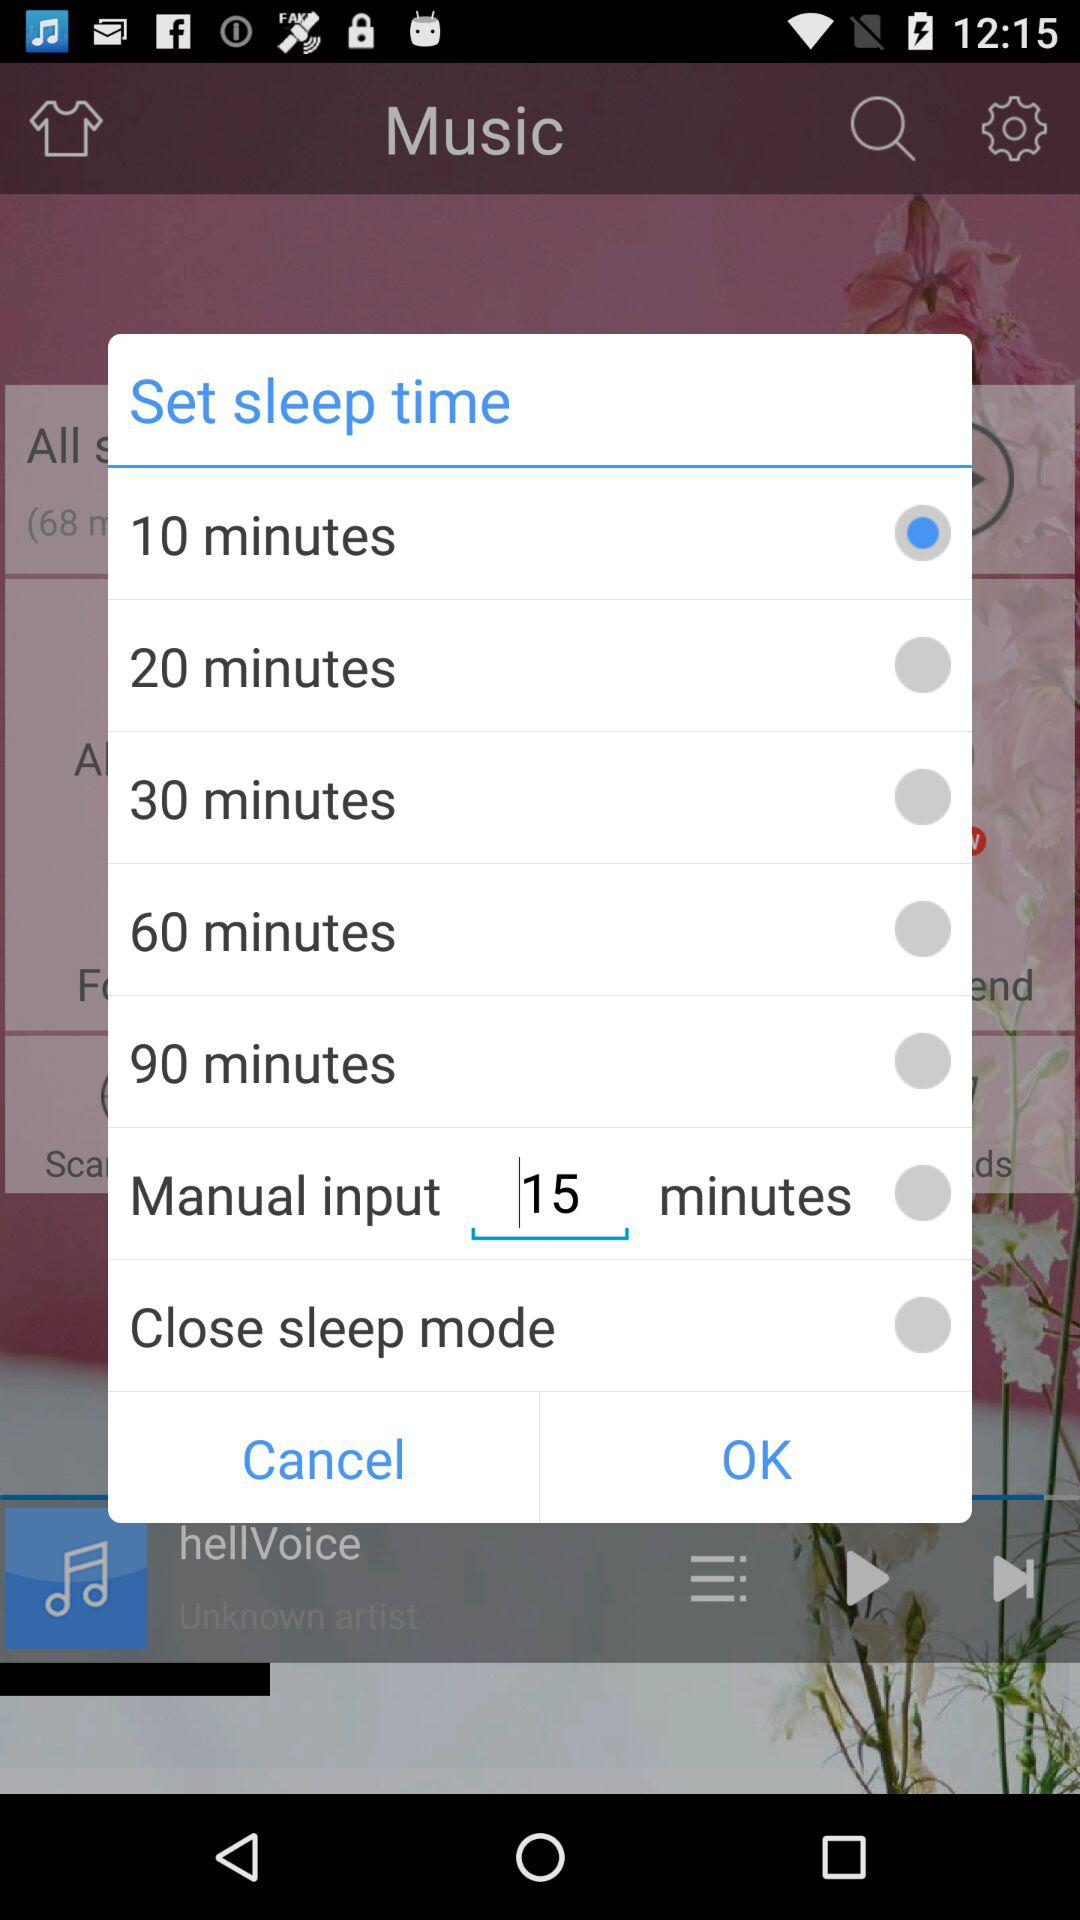How many minutes is the longest sleep time available?
Answer the question using a single word or phrase. 90 minutes 